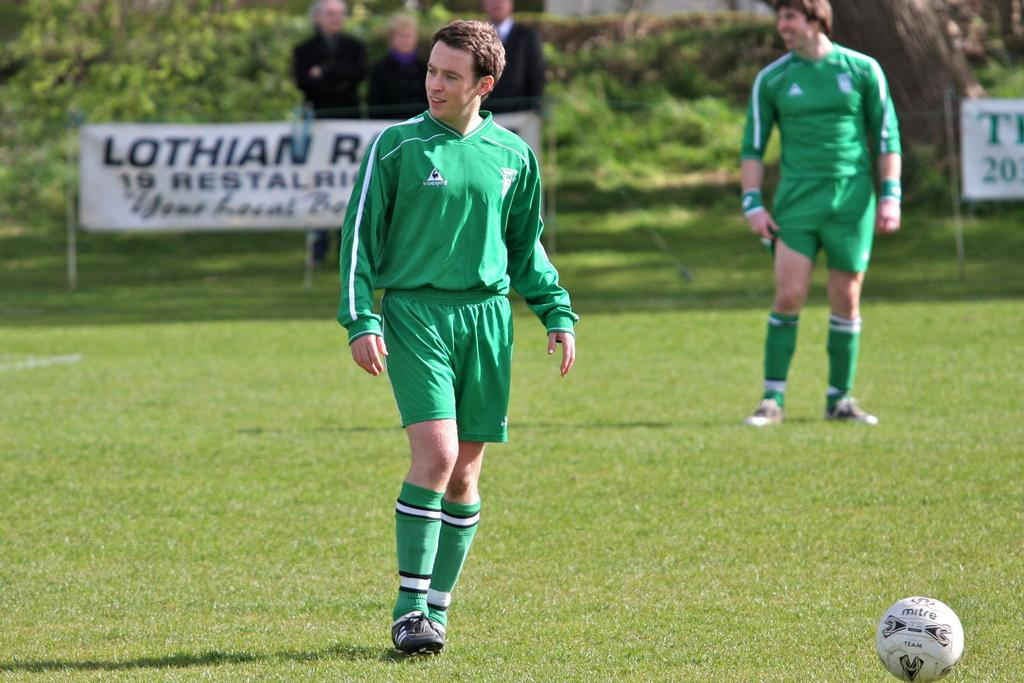How many players are on the playground in the image? There are two players on the playground in the image. What object is visible in the image that is commonly used in sports? There is a ball in the image. Who else is present in the image besides the players? There are spectators in the image. What decorative elements can be seen in the image? There are banners in the image. What can be seen in the background of the image? There are trees in the background of the image. What type of stocking is hanging from the tree in the image? There is no stocking hanging from the tree in the image. Can you describe the swing that is present in the image? There is no swing present in the image. 